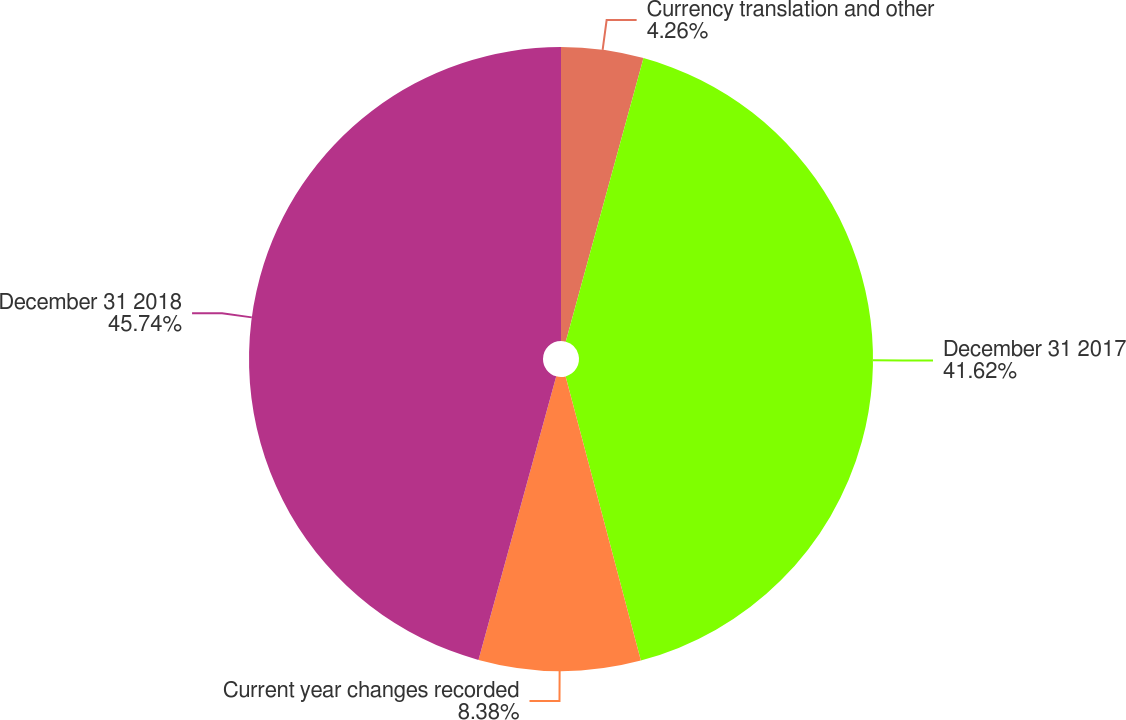Convert chart. <chart><loc_0><loc_0><loc_500><loc_500><pie_chart><fcel>Currency translation and other<fcel>December 31 2017<fcel>Current year changes recorded<fcel>December 31 2018<nl><fcel>4.26%<fcel>41.62%<fcel>8.38%<fcel>45.74%<nl></chart> 